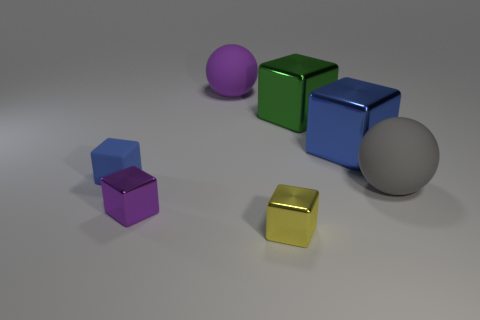Can you describe the colors of the objects in the image? Certainly! The image features objects with a variety of colors. There is a purple sphere, a pair of cubes that are green and blue, respectively, a smaller cube that's purple, and a smaller cube with a gold or yellowish tone. Lastly, there is a large gray sphere and a small silver sphere. 